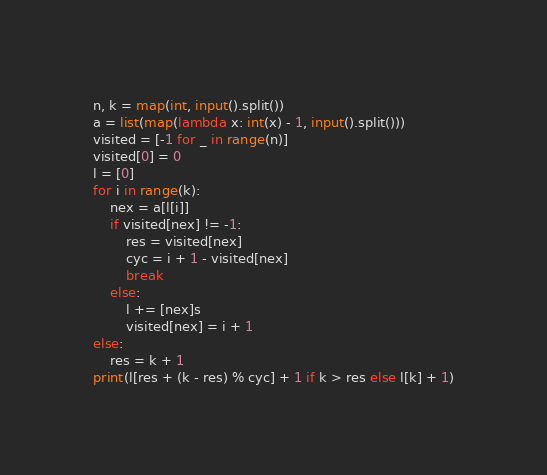Convert code to text. <code><loc_0><loc_0><loc_500><loc_500><_Python_>n, k = map(int, input().split())
a = list(map(lambda x: int(x) - 1, input().split()))
visited = [-1 for _ in range(n)]
visited[0] = 0
l = [0]
for i in range(k):
    nex = a[l[i]]
    if visited[nex] != -1:
        res = visited[nex]
        cyc = i + 1 - visited[nex]
        break
    else:
        l += [nex]s
        visited[nex] = i + 1
else:
    res = k + 1
print(l[res + (k - res) % cyc] + 1 if k > res else l[k] + 1)
</code> 